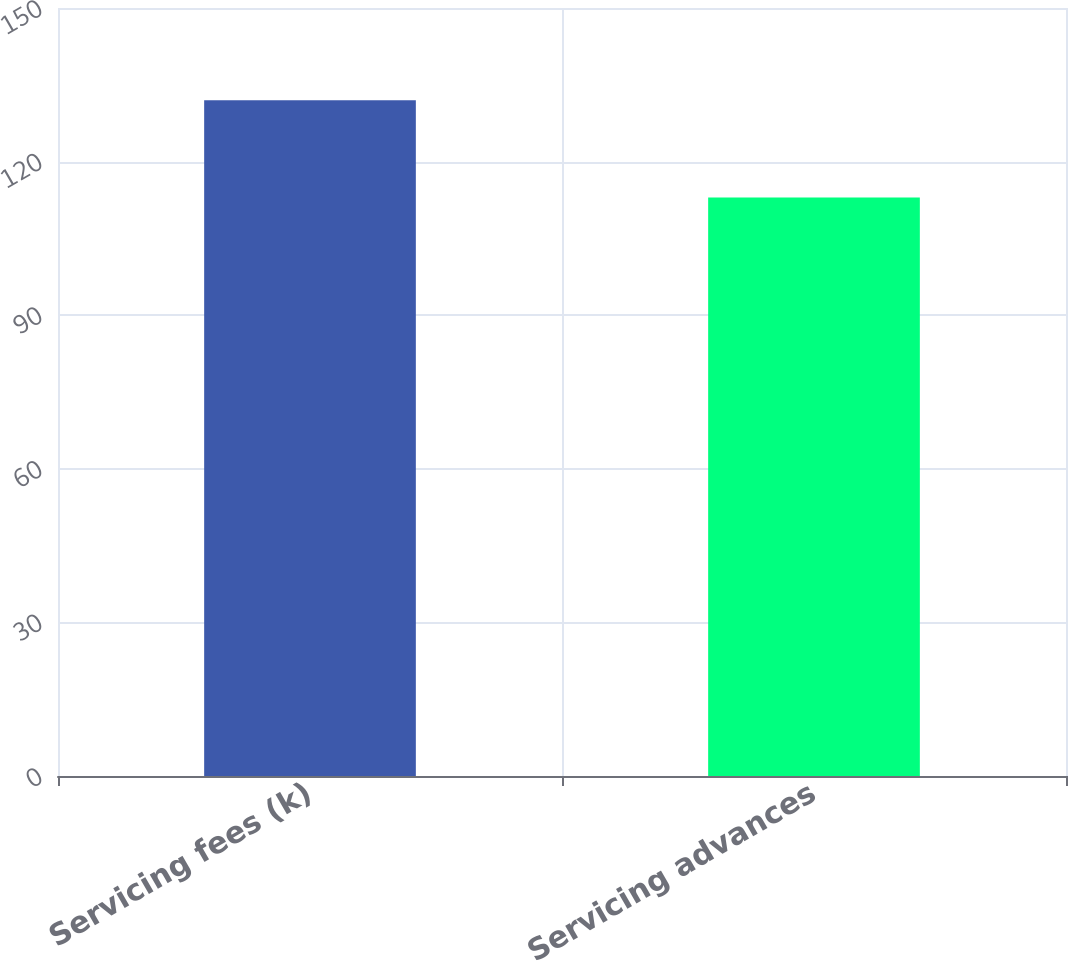Convert chart. <chart><loc_0><loc_0><loc_500><loc_500><bar_chart><fcel>Servicing fees (k)<fcel>Servicing advances<nl><fcel>132<fcel>113<nl></chart> 